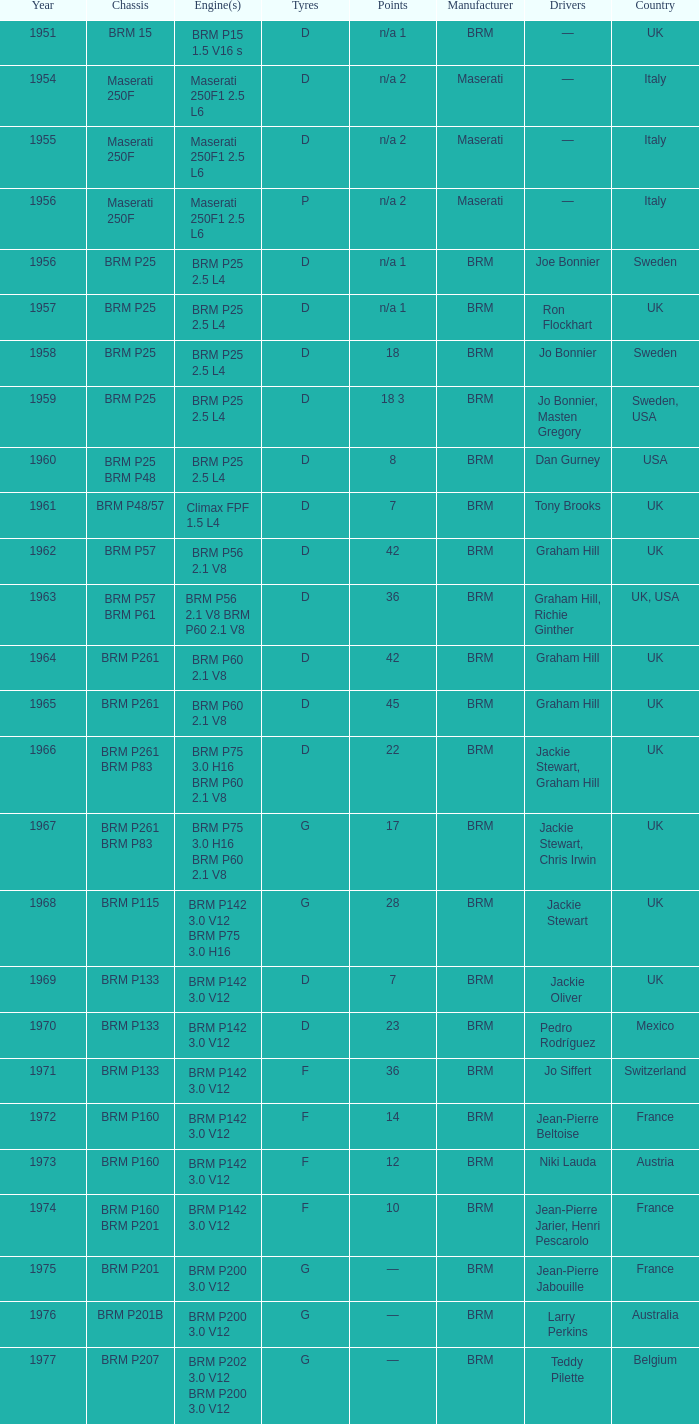What was the notable milestone in 1974? 10.0. 